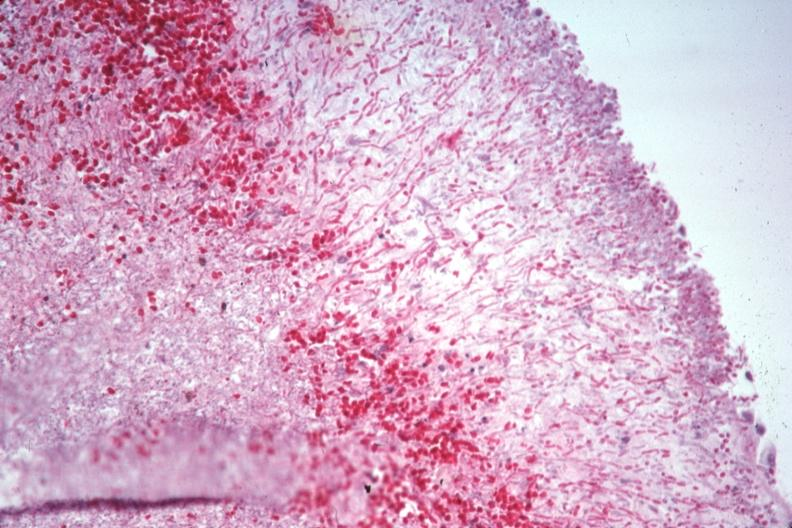what is present?
Answer the question using a single word or phrase. Hematologic 